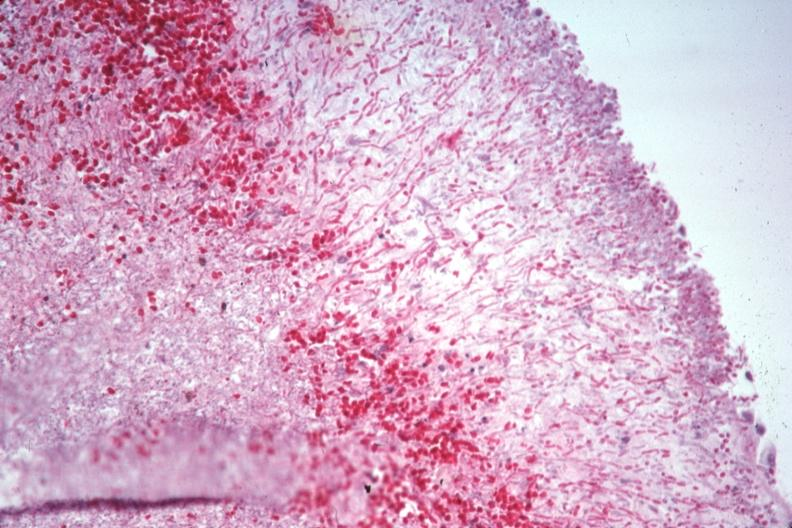what is present?
Answer the question using a single word or phrase. Hematologic 